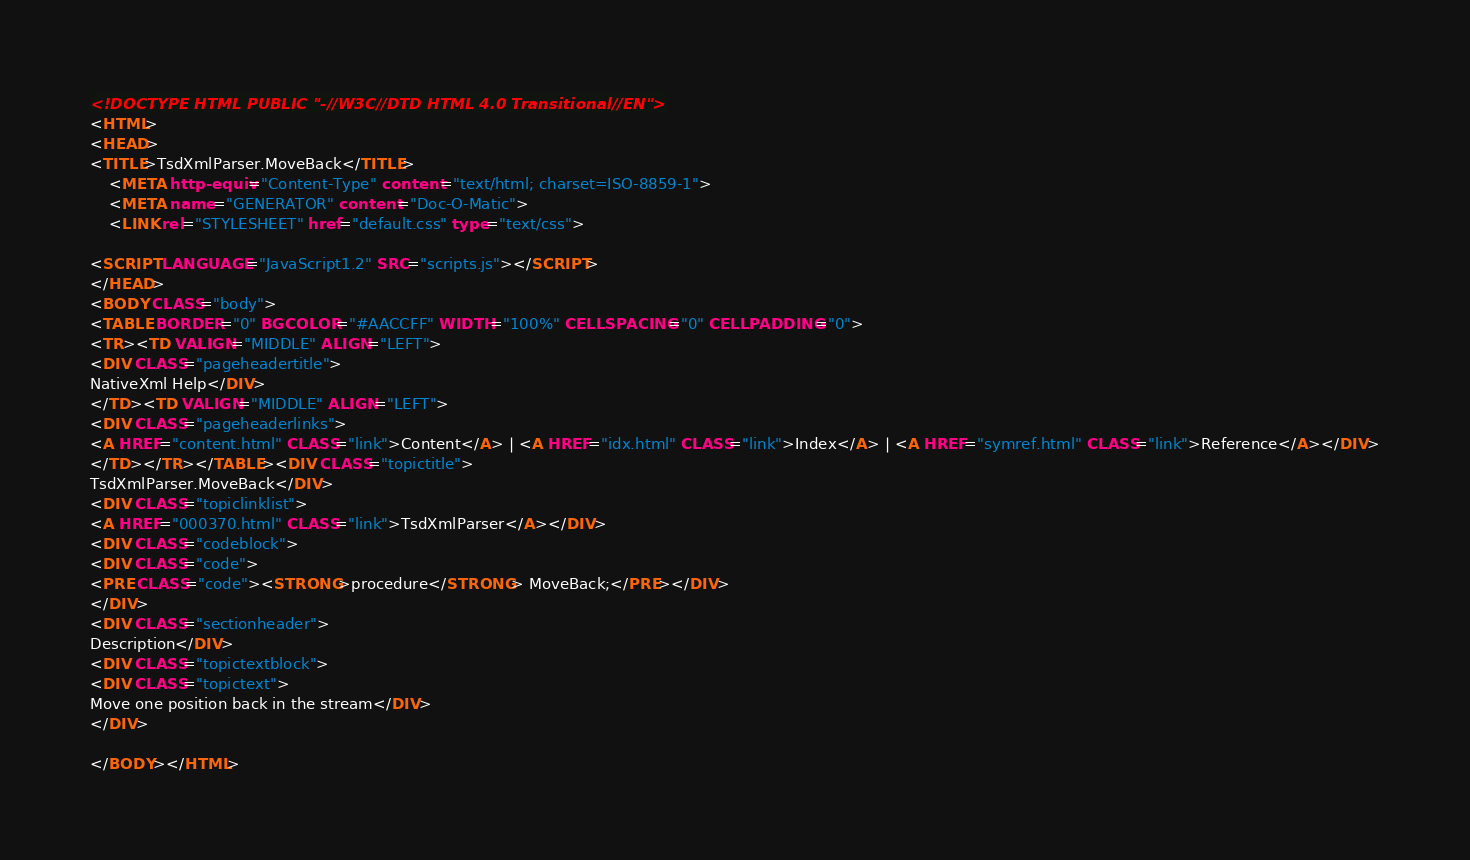Convert code to text. <code><loc_0><loc_0><loc_500><loc_500><_HTML_><!DOCTYPE HTML PUBLIC "-//W3C//DTD HTML 4.0 Transitional//EN">
<HTML>
<HEAD>
<TITLE>TsdXmlParser.MoveBack</TITLE>
    <META http-equiv="Content-Type" content="text/html; charset=ISO-8859-1">
    <META name="GENERATOR" content="Doc-O-Matic">
    <LINK rel="STYLESHEET" href="default.css" type="text/css">

<SCRIPT LANGUAGE="JavaScript1.2" SRC="scripts.js"></SCRIPT>
</HEAD>
<BODY CLASS="body">
<TABLE BORDER="0" BGCOLOR="#AACCFF" WIDTH="100%" CELLSPACING="0" CELLPADDING="0">
<TR><TD VALIGN="MIDDLE" ALIGN="LEFT">
<DIV CLASS="pageheadertitle">
NativeXml Help</DIV>
</TD><TD VALIGN="MIDDLE" ALIGN="LEFT">
<DIV CLASS="pageheaderlinks">
<A HREF="content.html" CLASS="link">Content</A> | <A HREF="idx.html" CLASS="link">Index</A> | <A HREF="symref.html" CLASS="link">Reference</A></DIV>
</TD></TR></TABLE><DIV CLASS="topictitle">
TsdXmlParser.MoveBack</DIV>
<DIV CLASS="topiclinklist">
<A HREF="000370.html" CLASS="link">TsdXmlParser</A></DIV>
<DIV CLASS="codeblock">
<DIV CLASS="code">
<PRE CLASS="code"><STRONG>procedure</STRONG> MoveBack;</PRE></DIV>
</DIV>
<DIV CLASS="sectionheader">
Description</DIV>
<DIV CLASS="topictextblock">
<DIV CLASS="topictext">
Move one position back in the stream</DIV>
</DIV>

</BODY></HTML></code> 